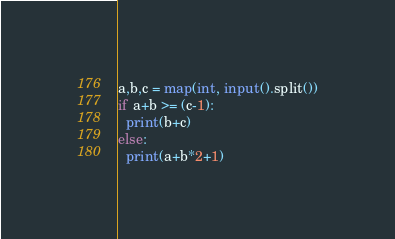Convert code to text. <code><loc_0><loc_0><loc_500><loc_500><_Python_>a,b,c = map(int, input().split())
if a+b >= (c-1):
  print(b+c)
else:
  print(a+b*2+1)</code> 